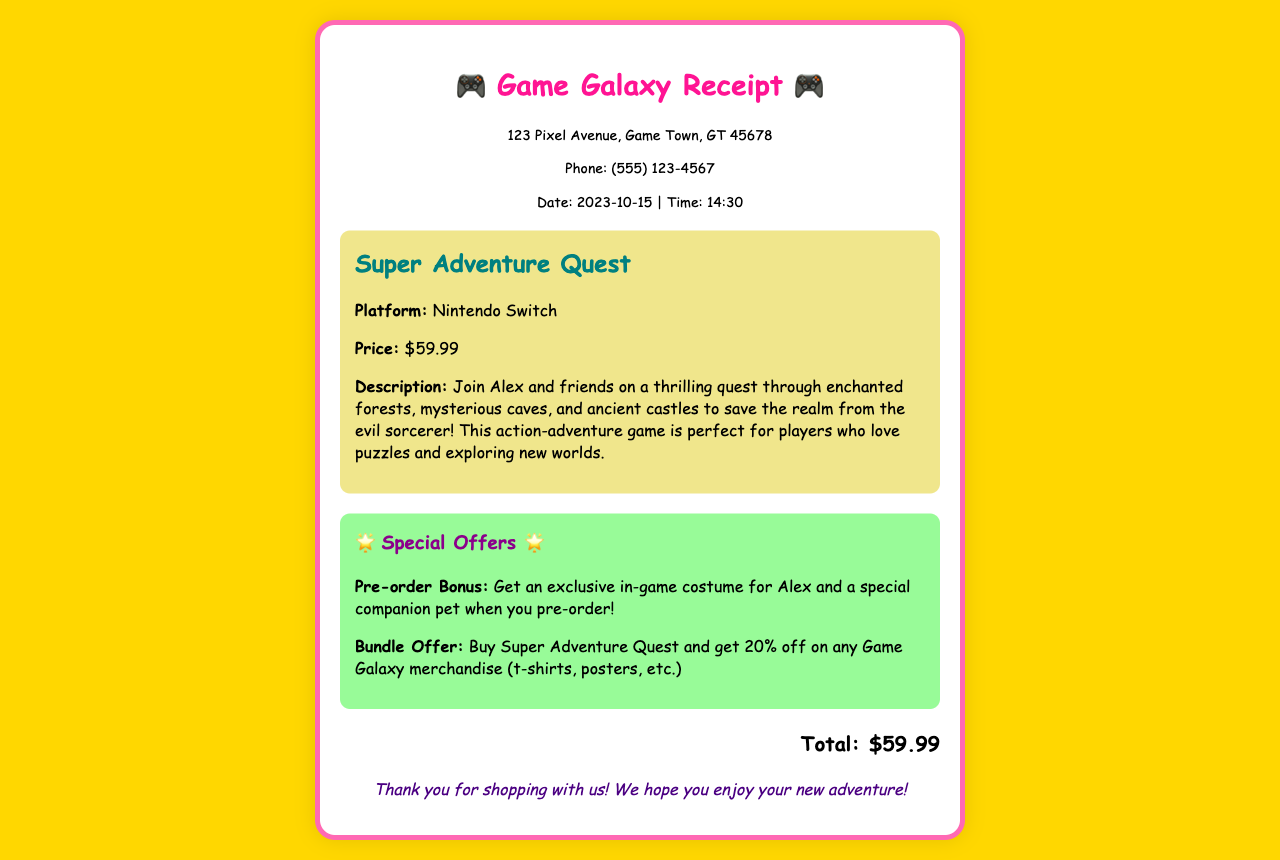What is the title of the game? The title of the game is stated at the beginning of the item section in the receipt.
Answer: Super Adventure Quest What platform is the game available on? The platform for the game is mentioned in the item description.
Answer: Nintendo Switch What is the price of the game? The price is clearly listed in the item section of the receipt.
Answer: $59.99 What is the pre-order bonus? The pre-order bonus is mentioned in the special offers section.
Answer: Exclusive in-game costume for Alex and a special companion pet What percentage discount is offered for the bundle? The discount for the bundle offer is specified in the special offers section.
Answer: 20% What date was the receipt issued? The date of the receipt is provided in the store information section.
Answer: 2023-10-15 What is the main goal of the game? The main goal of the game is described in the item section, outlining the quest.
Answer: Save the realm from the evil sorcerer What is the store's phone number? The phone number of the store is listed in the store information section.
Answer: (555) 123-4567 What is included in the special companion pet offer? The special companion pet offer is mentioned in the special offers section.
Answer: A special companion pet 